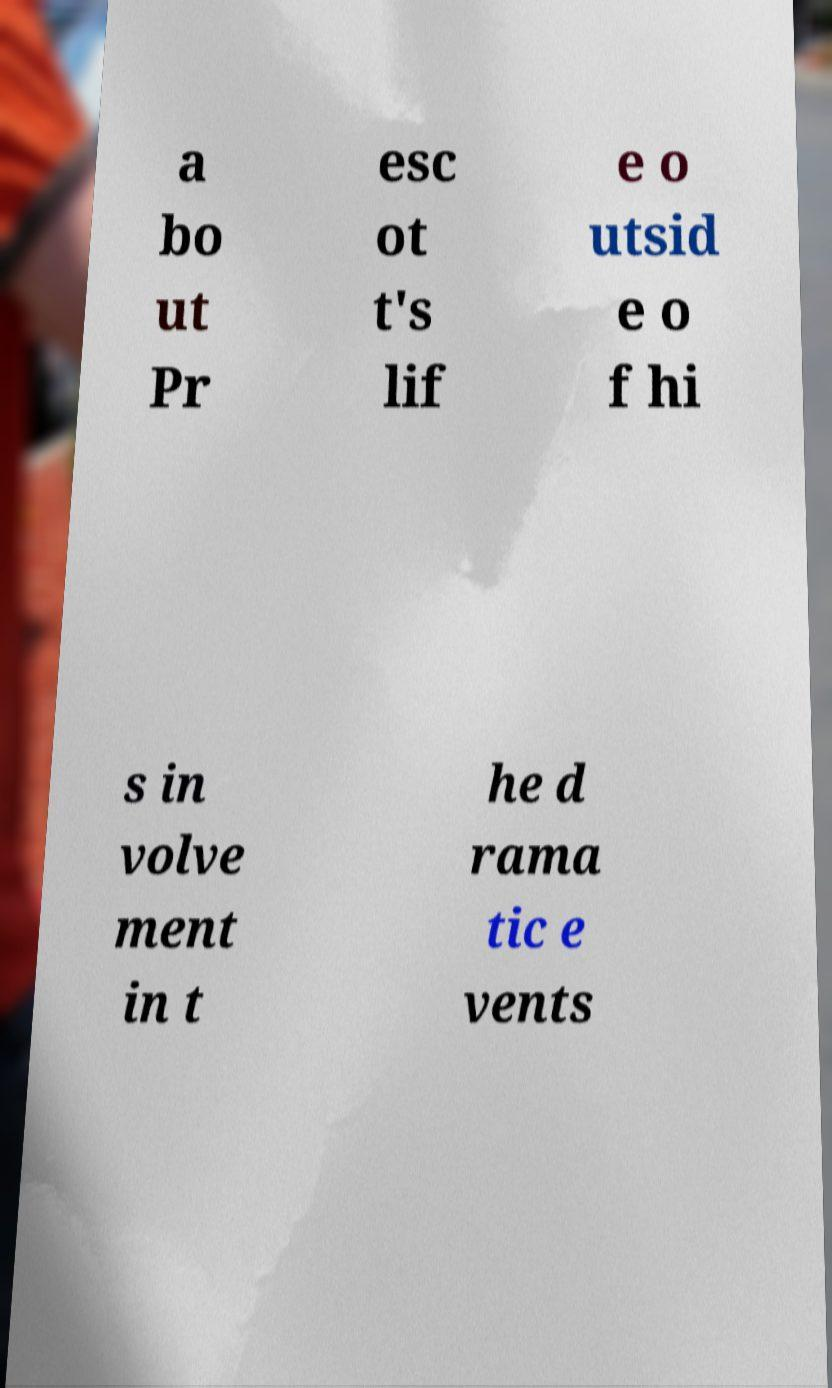Can you read and provide the text displayed in the image?This photo seems to have some interesting text. Can you extract and type it out for me? a bo ut Pr esc ot t's lif e o utsid e o f hi s in volve ment in t he d rama tic e vents 